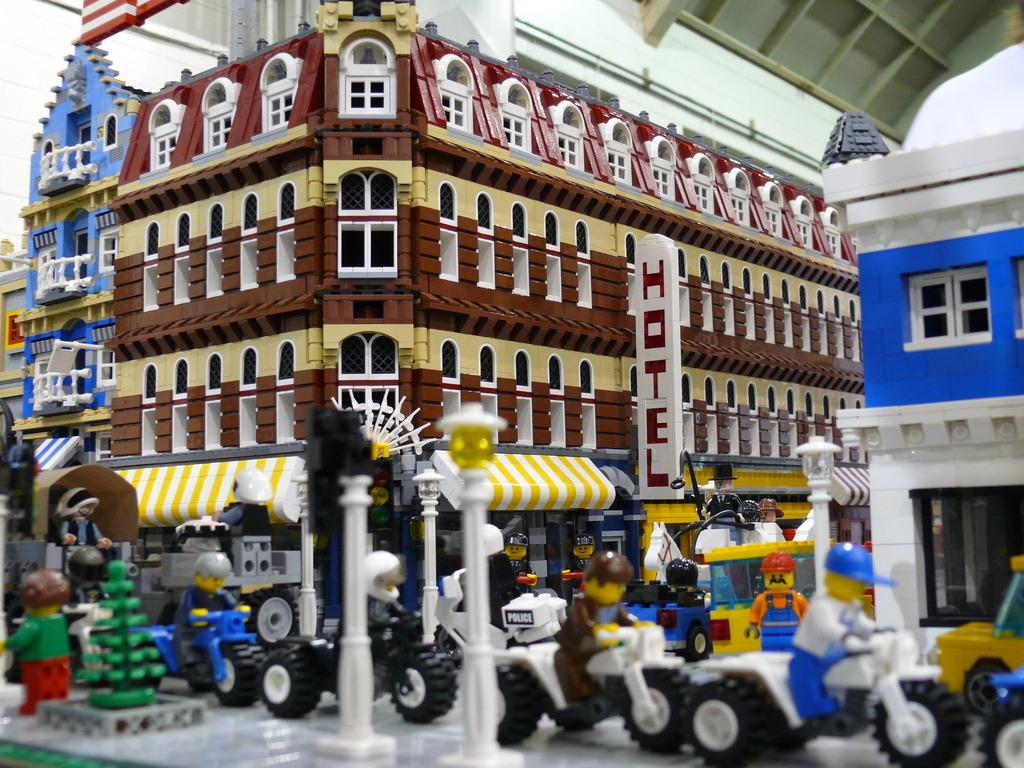What types of structures are depicted in the image? There are depictions of buildings in the image. What else can be seen in the image besides buildings? There are depictions of vehicles and people in the image. Can you tell me how many rifles are being carried by the people in the image? There are no rifles present in the image; it only depicts buildings, vehicles, and people. Is there a boy visible in the image? The provided facts do not mention the presence of a boy, so we cannot definitively answer that question. 